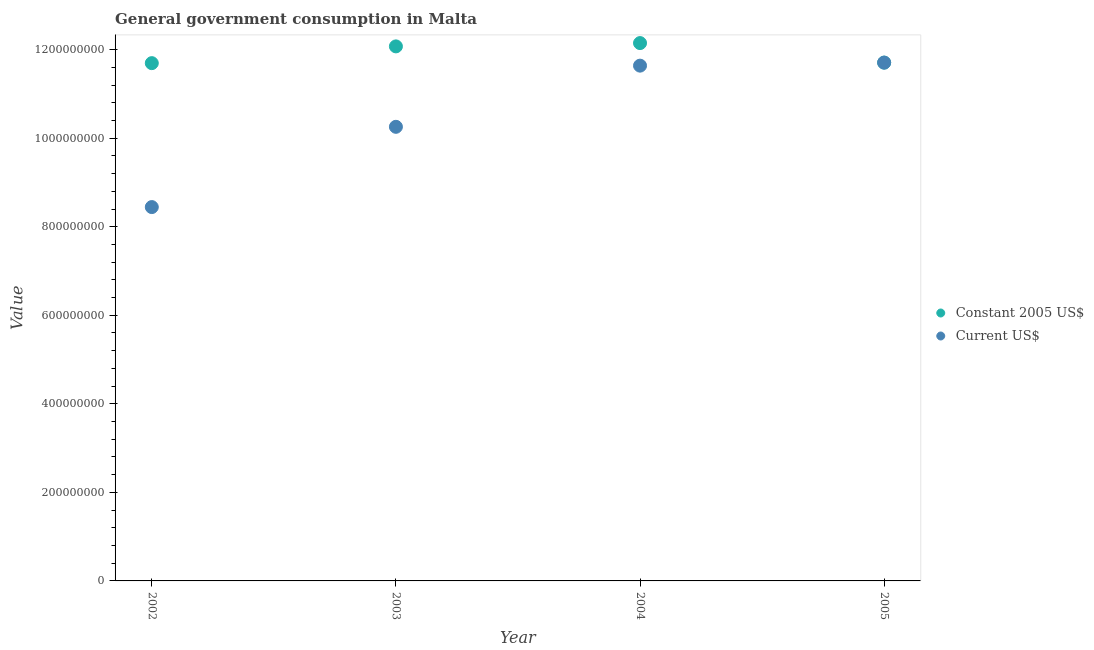How many different coloured dotlines are there?
Your response must be concise. 2. What is the value consumed in constant 2005 us$ in 2005?
Your answer should be very brief. 1.17e+09. Across all years, what is the maximum value consumed in constant 2005 us$?
Your answer should be very brief. 1.21e+09. Across all years, what is the minimum value consumed in constant 2005 us$?
Your answer should be compact. 1.17e+09. In which year was the value consumed in current us$ maximum?
Provide a short and direct response. 2005. What is the total value consumed in current us$ in the graph?
Your response must be concise. 4.20e+09. What is the difference between the value consumed in constant 2005 us$ in 2002 and that in 2004?
Keep it short and to the point. -4.53e+07. What is the difference between the value consumed in current us$ in 2003 and the value consumed in constant 2005 us$ in 2005?
Provide a succinct answer. -1.45e+08. What is the average value consumed in current us$ per year?
Keep it short and to the point. 1.05e+09. In the year 2002, what is the difference between the value consumed in current us$ and value consumed in constant 2005 us$?
Provide a short and direct response. -3.25e+08. In how many years, is the value consumed in current us$ greater than 200000000?
Make the answer very short. 4. What is the ratio of the value consumed in current us$ in 2003 to that in 2005?
Make the answer very short. 0.88. Is the value consumed in current us$ in 2002 less than that in 2005?
Provide a short and direct response. Yes. Is the difference between the value consumed in current us$ in 2003 and 2005 greater than the difference between the value consumed in constant 2005 us$ in 2003 and 2005?
Keep it short and to the point. No. What is the difference between the highest and the second highest value consumed in current us$?
Keep it short and to the point. 6.87e+06. What is the difference between the highest and the lowest value consumed in constant 2005 us$?
Keep it short and to the point. 4.53e+07. Is the sum of the value consumed in current us$ in 2002 and 2004 greater than the maximum value consumed in constant 2005 us$ across all years?
Your answer should be compact. Yes. Is the value consumed in constant 2005 us$ strictly less than the value consumed in current us$ over the years?
Provide a succinct answer. No. What is the difference between two consecutive major ticks on the Y-axis?
Offer a very short reply. 2.00e+08. What is the title of the graph?
Ensure brevity in your answer.  General government consumption in Malta. Does "Pregnant women" appear as one of the legend labels in the graph?
Give a very brief answer. No. What is the label or title of the X-axis?
Make the answer very short. Year. What is the label or title of the Y-axis?
Offer a very short reply. Value. What is the Value in Constant 2005 US$ in 2002?
Provide a succinct answer. 1.17e+09. What is the Value in Current US$ in 2002?
Provide a succinct answer. 8.44e+08. What is the Value in Constant 2005 US$ in 2003?
Make the answer very short. 1.21e+09. What is the Value in Current US$ in 2003?
Provide a short and direct response. 1.03e+09. What is the Value of Constant 2005 US$ in 2004?
Give a very brief answer. 1.21e+09. What is the Value of Current US$ in 2004?
Give a very brief answer. 1.16e+09. What is the Value of Constant 2005 US$ in 2005?
Ensure brevity in your answer.  1.17e+09. What is the Value of Current US$ in 2005?
Keep it short and to the point. 1.17e+09. Across all years, what is the maximum Value of Constant 2005 US$?
Your answer should be very brief. 1.21e+09. Across all years, what is the maximum Value in Current US$?
Keep it short and to the point. 1.17e+09. Across all years, what is the minimum Value of Constant 2005 US$?
Give a very brief answer. 1.17e+09. Across all years, what is the minimum Value of Current US$?
Give a very brief answer. 8.44e+08. What is the total Value of Constant 2005 US$ in the graph?
Provide a short and direct response. 4.76e+09. What is the total Value in Current US$ in the graph?
Provide a short and direct response. 4.20e+09. What is the difference between the Value of Constant 2005 US$ in 2002 and that in 2003?
Your answer should be very brief. -3.79e+07. What is the difference between the Value in Current US$ in 2002 and that in 2003?
Give a very brief answer. -1.81e+08. What is the difference between the Value of Constant 2005 US$ in 2002 and that in 2004?
Provide a succinct answer. -4.53e+07. What is the difference between the Value in Current US$ in 2002 and that in 2004?
Offer a terse response. -3.19e+08. What is the difference between the Value in Constant 2005 US$ in 2002 and that in 2005?
Provide a short and direct response. -1.22e+06. What is the difference between the Value of Current US$ in 2002 and that in 2005?
Your answer should be very brief. -3.26e+08. What is the difference between the Value of Constant 2005 US$ in 2003 and that in 2004?
Provide a short and direct response. -7.48e+06. What is the difference between the Value of Current US$ in 2003 and that in 2004?
Keep it short and to the point. -1.38e+08. What is the difference between the Value in Constant 2005 US$ in 2003 and that in 2005?
Your answer should be very brief. 3.66e+07. What is the difference between the Value in Current US$ in 2003 and that in 2005?
Your answer should be very brief. -1.45e+08. What is the difference between the Value in Constant 2005 US$ in 2004 and that in 2005?
Your response must be concise. 4.41e+07. What is the difference between the Value of Current US$ in 2004 and that in 2005?
Keep it short and to the point. -6.87e+06. What is the difference between the Value in Constant 2005 US$ in 2002 and the Value in Current US$ in 2003?
Offer a terse response. 1.44e+08. What is the difference between the Value of Constant 2005 US$ in 2002 and the Value of Current US$ in 2004?
Provide a succinct answer. 5.64e+06. What is the difference between the Value of Constant 2005 US$ in 2002 and the Value of Current US$ in 2005?
Your answer should be very brief. -1.22e+06. What is the difference between the Value in Constant 2005 US$ in 2003 and the Value in Current US$ in 2004?
Offer a very short reply. 4.35e+07. What is the difference between the Value in Constant 2005 US$ in 2003 and the Value in Current US$ in 2005?
Keep it short and to the point. 3.66e+07. What is the difference between the Value in Constant 2005 US$ in 2004 and the Value in Current US$ in 2005?
Provide a succinct answer. 4.41e+07. What is the average Value of Constant 2005 US$ per year?
Provide a short and direct response. 1.19e+09. What is the average Value in Current US$ per year?
Offer a terse response. 1.05e+09. In the year 2002, what is the difference between the Value of Constant 2005 US$ and Value of Current US$?
Your answer should be very brief. 3.25e+08. In the year 2003, what is the difference between the Value in Constant 2005 US$ and Value in Current US$?
Offer a very short reply. 1.82e+08. In the year 2004, what is the difference between the Value in Constant 2005 US$ and Value in Current US$?
Make the answer very short. 5.10e+07. In the year 2005, what is the difference between the Value in Constant 2005 US$ and Value in Current US$?
Offer a terse response. 0. What is the ratio of the Value of Constant 2005 US$ in 2002 to that in 2003?
Provide a succinct answer. 0.97. What is the ratio of the Value of Current US$ in 2002 to that in 2003?
Make the answer very short. 0.82. What is the ratio of the Value in Constant 2005 US$ in 2002 to that in 2004?
Ensure brevity in your answer.  0.96. What is the ratio of the Value of Current US$ in 2002 to that in 2004?
Your answer should be very brief. 0.73. What is the ratio of the Value of Current US$ in 2002 to that in 2005?
Keep it short and to the point. 0.72. What is the ratio of the Value of Constant 2005 US$ in 2003 to that in 2004?
Make the answer very short. 0.99. What is the ratio of the Value in Current US$ in 2003 to that in 2004?
Give a very brief answer. 0.88. What is the ratio of the Value of Constant 2005 US$ in 2003 to that in 2005?
Offer a very short reply. 1.03. What is the ratio of the Value of Current US$ in 2003 to that in 2005?
Ensure brevity in your answer.  0.88. What is the ratio of the Value of Constant 2005 US$ in 2004 to that in 2005?
Your response must be concise. 1.04. What is the ratio of the Value in Current US$ in 2004 to that in 2005?
Your answer should be very brief. 0.99. What is the difference between the highest and the second highest Value of Constant 2005 US$?
Keep it short and to the point. 7.48e+06. What is the difference between the highest and the second highest Value in Current US$?
Keep it short and to the point. 6.87e+06. What is the difference between the highest and the lowest Value of Constant 2005 US$?
Make the answer very short. 4.53e+07. What is the difference between the highest and the lowest Value in Current US$?
Your answer should be compact. 3.26e+08. 